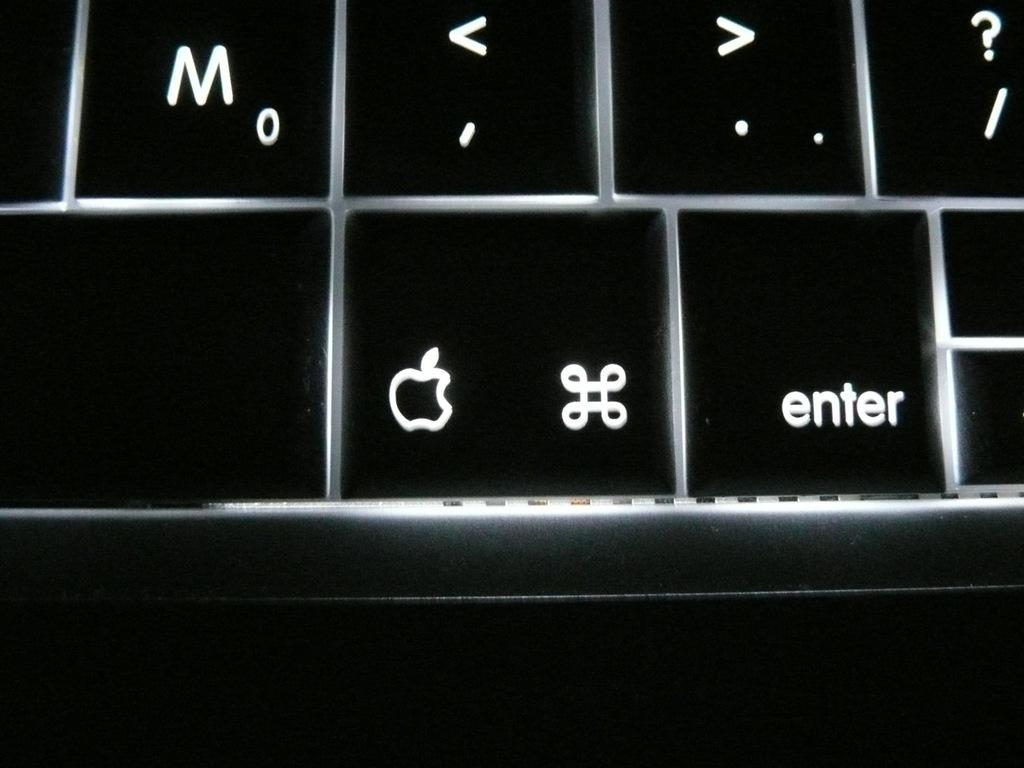<image>
Summarize the visual content of the image. A picture of a keyboard with the enter key visible. 